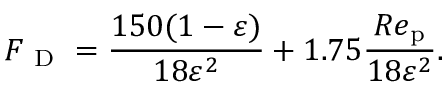<formula> <loc_0><loc_0><loc_500><loc_500>{ F _ { D } } = \frac { 1 5 0 ( 1 - \varepsilon ) } { 1 8 \varepsilon ^ { 2 } } + 1 . 7 5 \frac { R e _ { p } } { 1 8 \varepsilon ^ { 2 } } .</formula> 